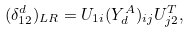<formula> <loc_0><loc_0><loc_500><loc_500>( \delta ^ { d } _ { 1 2 } ) _ { L R } = U _ { 1 i } ( Y ^ { A } _ { d } ) _ { i j } U ^ { T } _ { j 2 } ,</formula> 